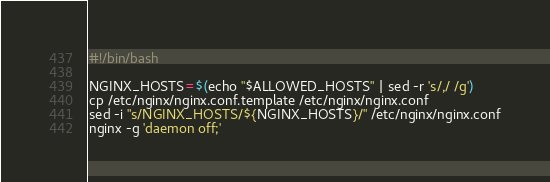<code> <loc_0><loc_0><loc_500><loc_500><_Bash_>#!/bin/bash

NGINX_HOSTS=$(echo "$ALLOWED_HOSTS" | sed -r 's/,/ /g')
cp /etc/nginx/nginx.conf.template /etc/nginx/nginx.conf
sed -i "s/NGINX_HOSTS/${NGINX_HOSTS}/" /etc/nginx/nginx.conf
nginx -g 'daemon off;'
</code> 